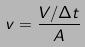Convert formula to latex. <formula><loc_0><loc_0><loc_500><loc_500>v = \frac { V / \Delta t } { A }</formula> 